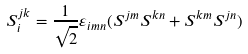Convert formula to latex. <formula><loc_0><loc_0><loc_500><loc_500>S ^ { j k } _ { i } = \frac { 1 } { \sqrt { 2 } } \varepsilon _ { i m n } ( S ^ { j m } S ^ { k n } + S ^ { k m } S ^ { j n } )</formula> 